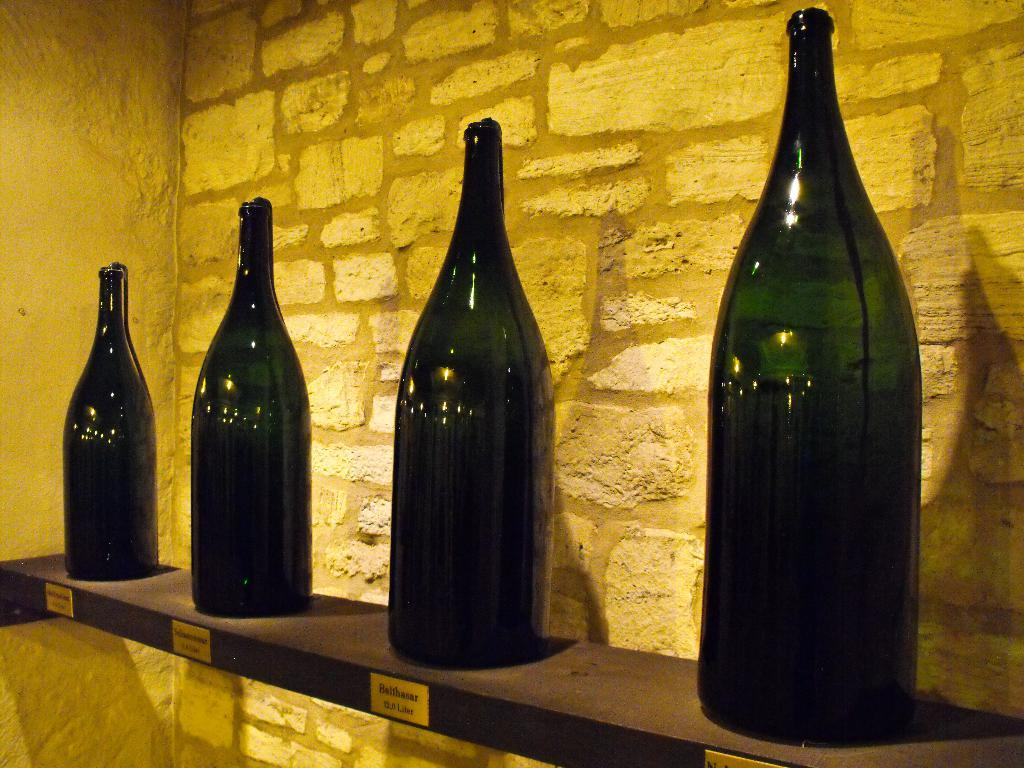What objects can be seen in the image? There are bottles in the image. What is on the wooden desk in the image? There is written text on a wooden desk. What can be seen in the background of the image? There is a wall in the background of the image. What type of punishment is being administered in the image? There is no indication of punishment in the image; it features bottles and a wooden desk with written text. 